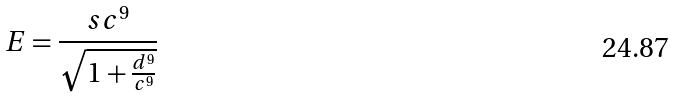Convert formula to latex. <formula><loc_0><loc_0><loc_500><loc_500>E = \frac { s c ^ { 9 } } { \sqrt { 1 + \frac { d ^ { 9 } } { c ^ { 9 } } } }</formula> 